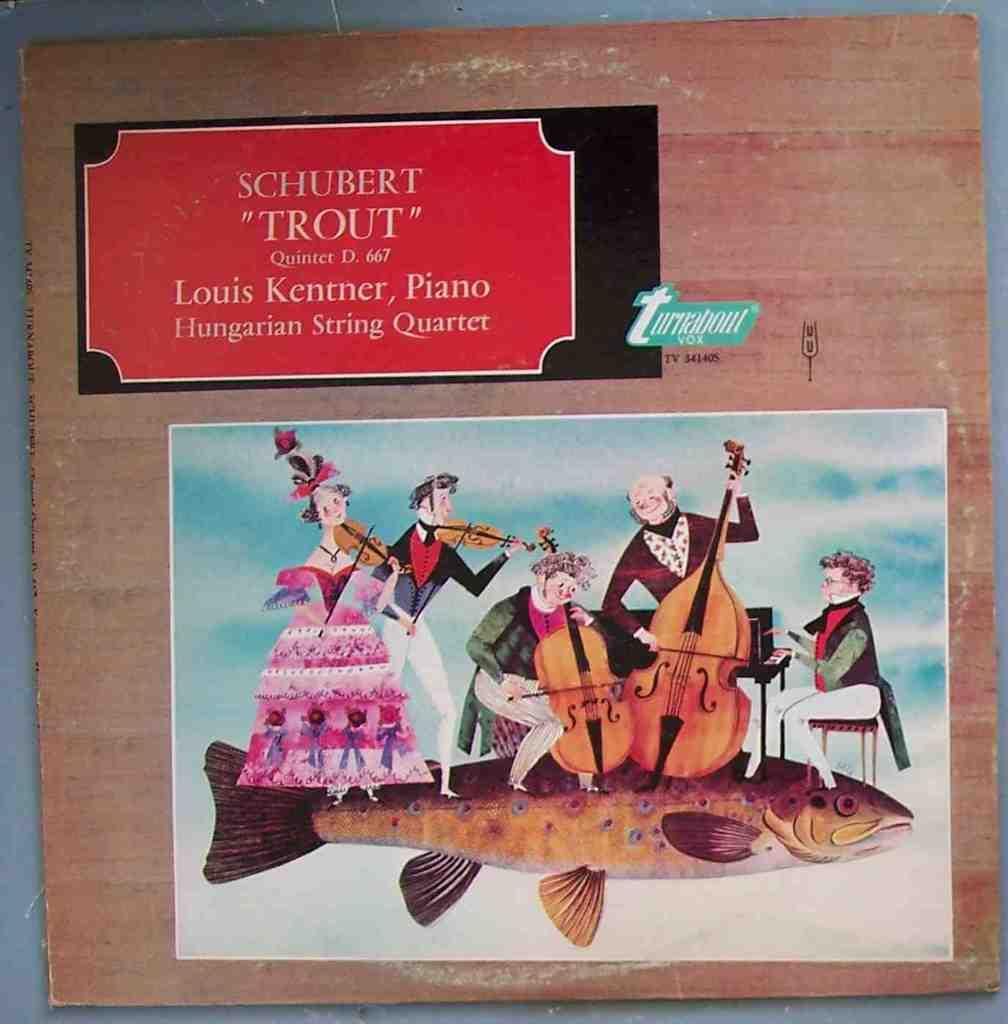Provide a one-sentence caption for the provided image. A picture named, "Trout" by Louis Kentner Piano. 